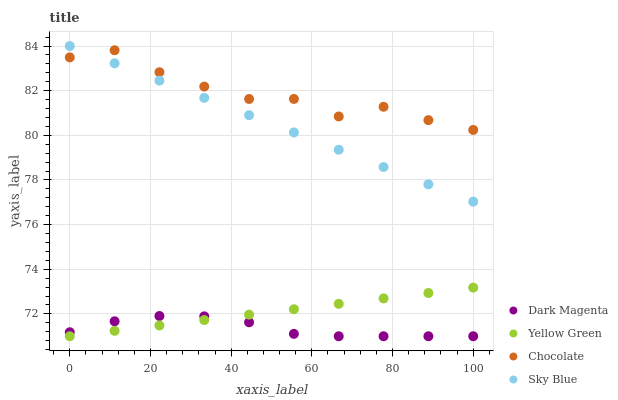Does Dark Magenta have the minimum area under the curve?
Answer yes or no. Yes. Does Chocolate have the maximum area under the curve?
Answer yes or no. Yes. Does Chocolate have the minimum area under the curve?
Answer yes or no. No. Does Dark Magenta have the maximum area under the curve?
Answer yes or no. No. Is Yellow Green the smoothest?
Answer yes or no. Yes. Is Chocolate the roughest?
Answer yes or no. Yes. Is Dark Magenta the smoothest?
Answer yes or no. No. Is Dark Magenta the roughest?
Answer yes or no. No. Does Dark Magenta have the lowest value?
Answer yes or no. Yes. Does Chocolate have the lowest value?
Answer yes or no. No. Does Sky Blue have the highest value?
Answer yes or no. Yes. Does Chocolate have the highest value?
Answer yes or no. No. Is Yellow Green less than Chocolate?
Answer yes or no. Yes. Is Chocolate greater than Dark Magenta?
Answer yes or no. Yes. Does Sky Blue intersect Chocolate?
Answer yes or no. Yes. Is Sky Blue less than Chocolate?
Answer yes or no. No. Is Sky Blue greater than Chocolate?
Answer yes or no. No. Does Yellow Green intersect Chocolate?
Answer yes or no. No. 